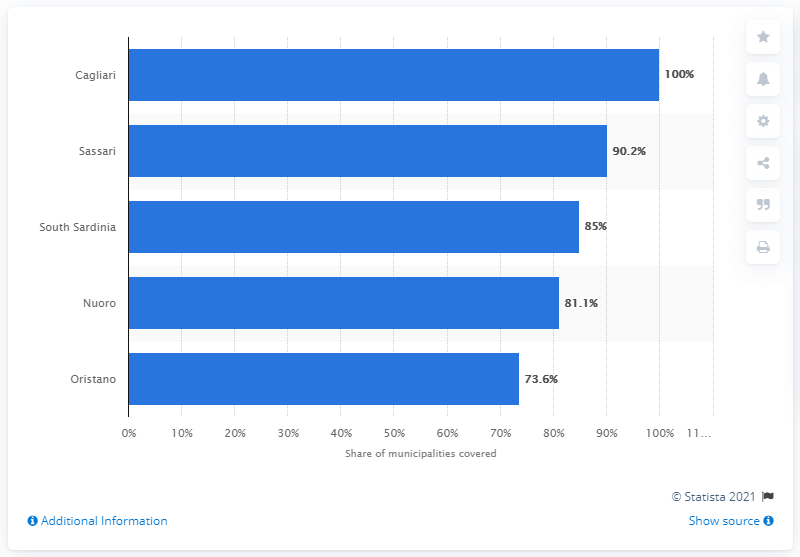List a handful of essential elements in this visual. Oristano, a province in Sardinia, had the lowest 4G penetration. In 2018, the 4G/4G Plus network was available in the province of Cagliari. 